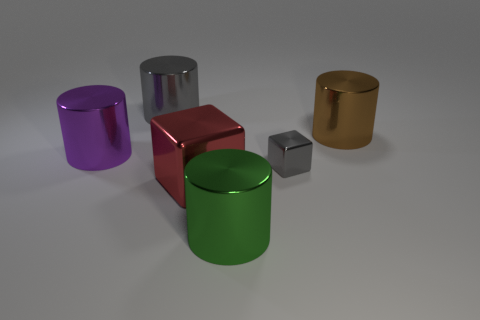Is the color of the metal cylinder on the left side of the gray cylinder the same as the large block in front of the small metal thing?
Offer a very short reply. No. What color is the metal cylinder that is on the right side of the small cube?
Your answer should be compact. Brown. There is a shiny cylinder that is behind the brown cylinder; is it the same size as the big purple shiny object?
Give a very brief answer. Yes. Is the number of large blue cylinders less than the number of red metallic things?
Give a very brief answer. Yes. What number of cylinders are to the right of the red block?
Your response must be concise. 2. Is the shape of the tiny gray metal thing the same as the red metallic thing?
Offer a terse response. Yes. How many objects are both on the right side of the red metal thing and in front of the small gray metal object?
Your answer should be very brief. 1. How many objects are either big metallic cubes or large green objects that are on the right side of the large cube?
Make the answer very short. 2. Are there more big cylinders than brown shiny balls?
Your response must be concise. Yes. There is a big shiny object that is behind the brown cylinder; what is its shape?
Your answer should be very brief. Cylinder. 